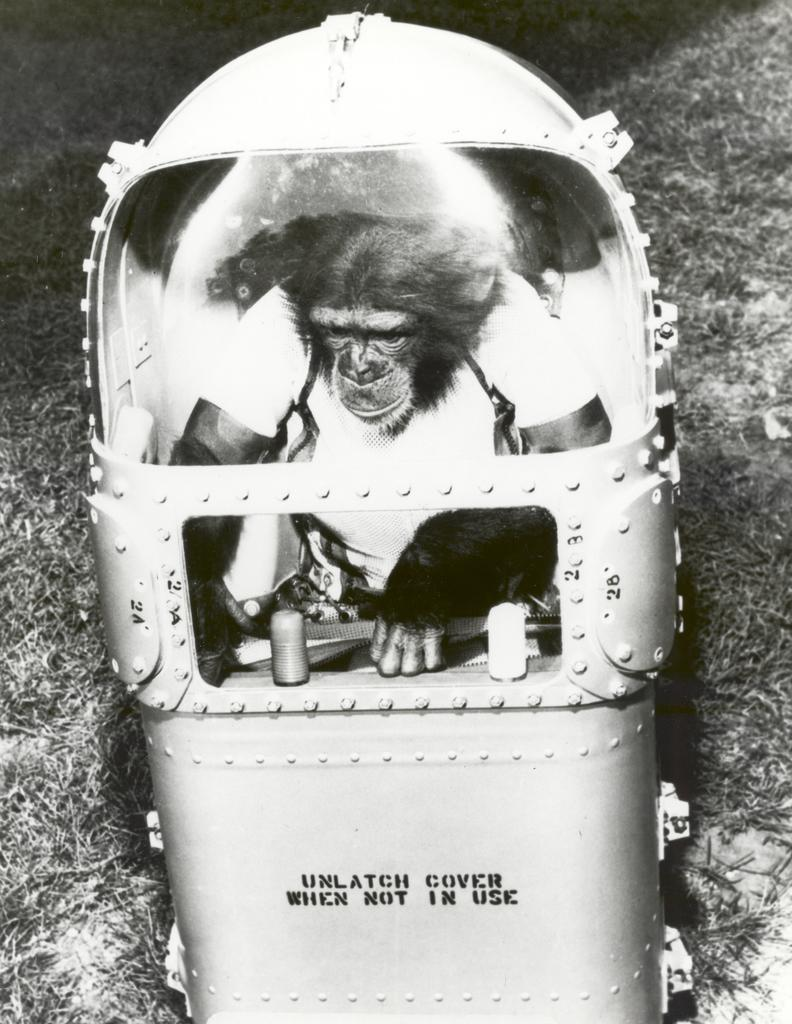What animal is present in the image? There is a monkey in the image. Where is the monkey located? The monkey is in a box. What type of vegetation can be seen in the background of the image? There is grass visible in the background of the image. What shape is the basketball in the image? There is no basketball present in the image. What scientific discovery is the monkey making in the image? The image does not depict any scientific discovery; it simply shows a monkey in a box. 